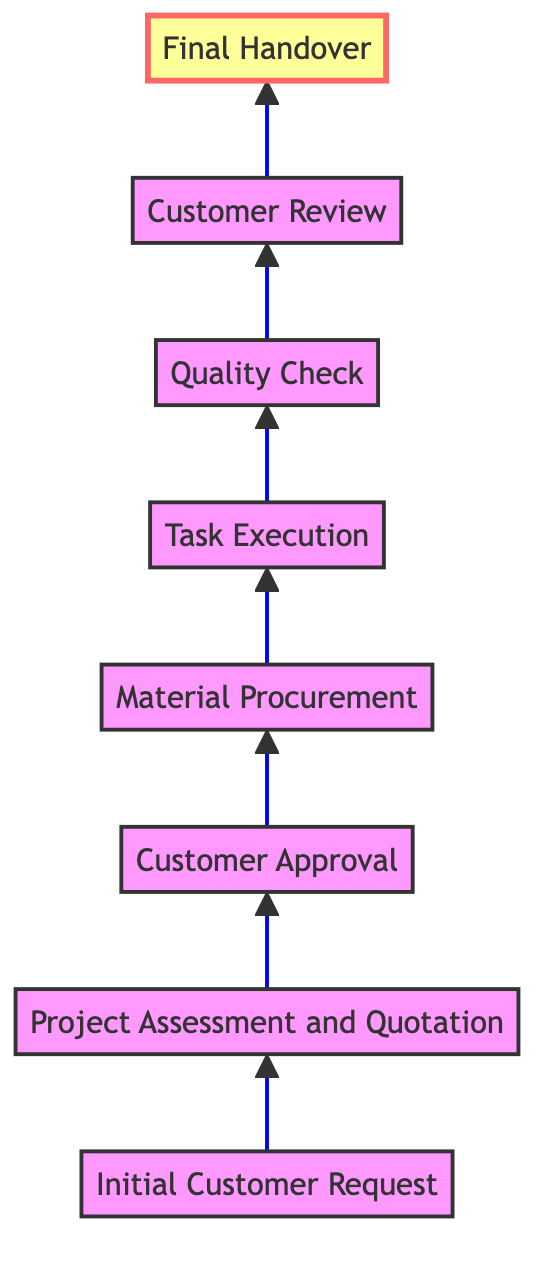What is the first step in the project completion process? The diagram outlines the steps to project completion, starting from the bottom. The first step is "Initial Customer Request," which is the base of the flow.
Answer: Initial Customer Request How many steps are there in total from start to finish? By counting each node listed in the diagram, we find there are eight distinct steps from "Initial Customer Request" to "Final Handover."
Answer: 8 What step comes immediately after "Customer Approval"? Looking at the flow, the node directly above "Customer Approval" is "Material Procurement," indicating the immediate next step in the process.
Answer: Material Procurement What is the final step in the process? Understanding that this diagram flows upward, the last node at the top is "Final Handover," which signifies the completion of the project.
Answer: Final Handover Which step involves assessing project requirements? The description of the node "Project Assessment and Quotation" includes the process of assessing project requirements and providing a quotation.
Answer: Project Assessment and Quotation What step follows "Quality Check"? According to the diagram, the node located above "Quality Check" is "Customer Review," meaning it follows the quality check in the process flow.
Answer: Customer Review What does "Task Execution" involve? Referring to the description of the "Task Execution" node, it describes the actual skilled labor tasks being performed according to the project plan.
Answer: Skilled labor tasks How many checks are performed before the final handover? Analyzing the diagram, there are two checkpoints before the final handover: "Quality Check" and "Customer Review."
Answer: 2 What action is required from the customer after receiving the quotation? After the quotation is provided, the next step where the customer's action is required is "Customer Approval," signifying their agreement to proceed.
Answer: Customer Approval 